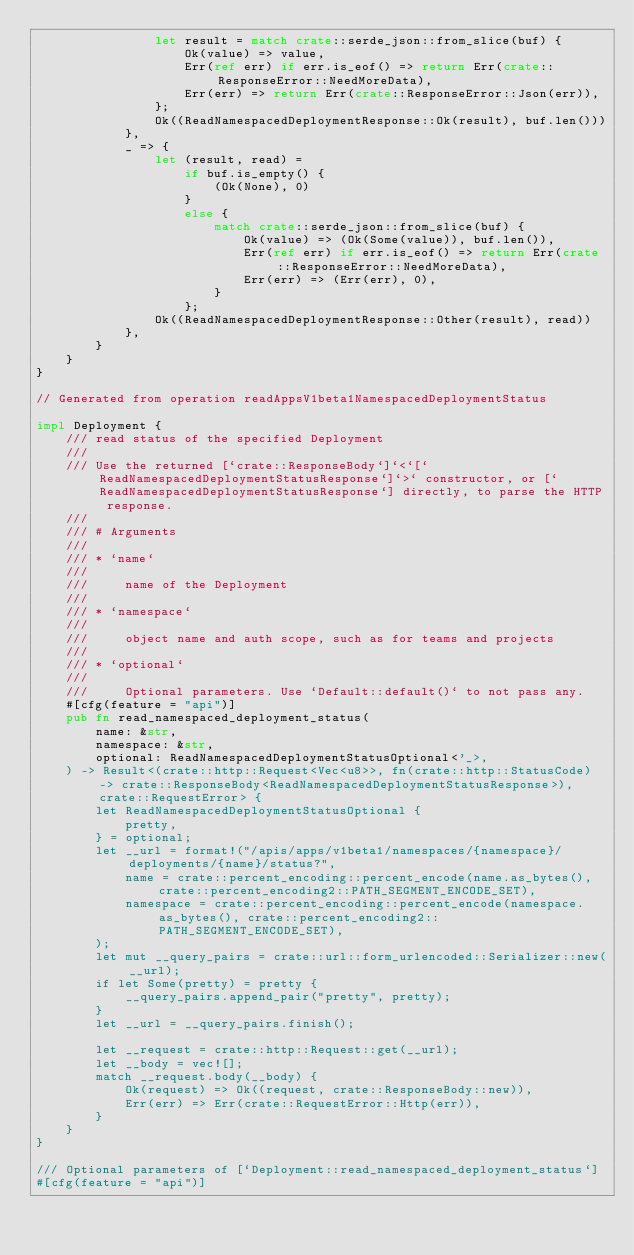<code> <loc_0><loc_0><loc_500><loc_500><_Rust_>                let result = match crate::serde_json::from_slice(buf) {
                    Ok(value) => value,
                    Err(ref err) if err.is_eof() => return Err(crate::ResponseError::NeedMoreData),
                    Err(err) => return Err(crate::ResponseError::Json(err)),
                };
                Ok((ReadNamespacedDeploymentResponse::Ok(result), buf.len()))
            },
            _ => {
                let (result, read) =
                    if buf.is_empty() {
                        (Ok(None), 0)
                    }
                    else {
                        match crate::serde_json::from_slice(buf) {
                            Ok(value) => (Ok(Some(value)), buf.len()),
                            Err(ref err) if err.is_eof() => return Err(crate::ResponseError::NeedMoreData),
                            Err(err) => (Err(err), 0),
                        }
                    };
                Ok((ReadNamespacedDeploymentResponse::Other(result), read))
            },
        }
    }
}

// Generated from operation readAppsV1beta1NamespacedDeploymentStatus

impl Deployment {
    /// read status of the specified Deployment
    ///
    /// Use the returned [`crate::ResponseBody`]`<`[`ReadNamespacedDeploymentStatusResponse`]`>` constructor, or [`ReadNamespacedDeploymentStatusResponse`] directly, to parse the HTTP response.
    ///
    /// # Arguments
    ///
    /// * `name`
    ///
    ///     name of the Deployment
    ///
    /// * `namespace`
    ///
    ///     object name and auth scope, such as for teams and projects
    ///
    /// * `optional`
    ///
    ///     Optional parameters. Use `Default::default()` to not pass any.
    #[cfg(feature = "api")]
    pub fn read_namespaced_deployment_status(
        name: &str,
        namespace: &str,
        optional: ReadNamespacedDeploymentStatusOptional<'_>,
    ) -> Result<(crate::http::Request<Vec<u8>>, fn(crate::http::StatusCode) -> crate::ResponseBody<ReadNamespacedDeploymentStatusResponse>), crate::RequestError> {
        let ReadNamespacedDeploymentStatusOptional {
            pretty,
        } = optional;
        let __url = format!("/apis/apps/v1beta1/namespaces/{namespace}/deployments/{name}/status?",
            name = crate::percent_encoding::percent_encode(name.as_bytes(), crate::percent_encoding2::PATH_SEGMENT_ENCODE_SET),
            namespace = crate::percent_encoding::percent_encode(namespace.as_bytes(), crate::percent_encoding2::PATH_SEGMENT_ENCODE_SET),
        );
        let mut __query_pairs = crate::url::form_urlencoded::Serializer::new(__url);
        if let Some(pretty) = pretty {
            __query_pairs.append_pair("pretty", pretty);
        }
        let __url = __query_pairs.finish();

        let __request = crate::http::Request::get(__url);
        let __body = vec![];
        match __request.body(__body) {
            Ok(request) => Ok((request, crate::ResponseBody::new)),
            Err(err) => Err(crate::RequestError::Http(err)),
        }
    }
}

/// Optional parameters of [`Deployment::read_namespaced_deployment_status`]
#[cfg(feature = "api")]</code> 